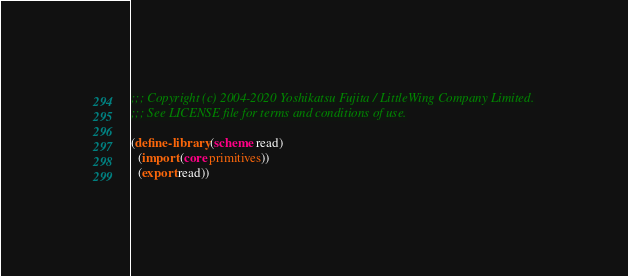<code> <loc_0><loc_0><loc_500><loc_500><_Scheme_>;;; Copyright (c) 2004-2020 Yoshikatsu Fujita / LittleWing Company Limited.
;;; See LICENSE file for terms and conditions of use.

(define-library (scheme read)
  (import (core primitives))
  (export read))
</code> 